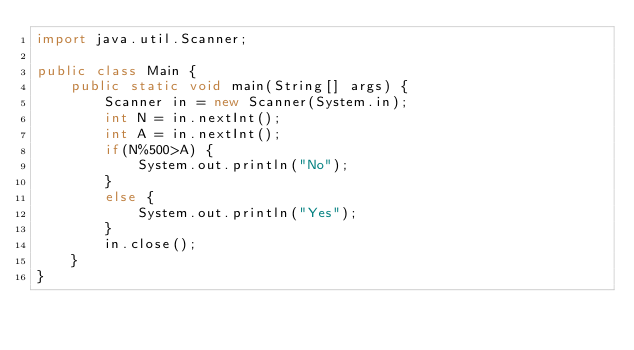Convert code to text. <code><loc_0><loc_0><loc_500><loc_500><_Java_>import java.util.Scanner;

public class Main {
	public static void main(String[] args) {
		Scanner in = new Scanner(System.in);
		int N = in.nextInt();
		int A = in.nextInt();
		if(N%500>A) {
			System.out.println("No");
		}
		else {
			System.out.println("Yes");
		}
		in.close();
	}
}</code> 